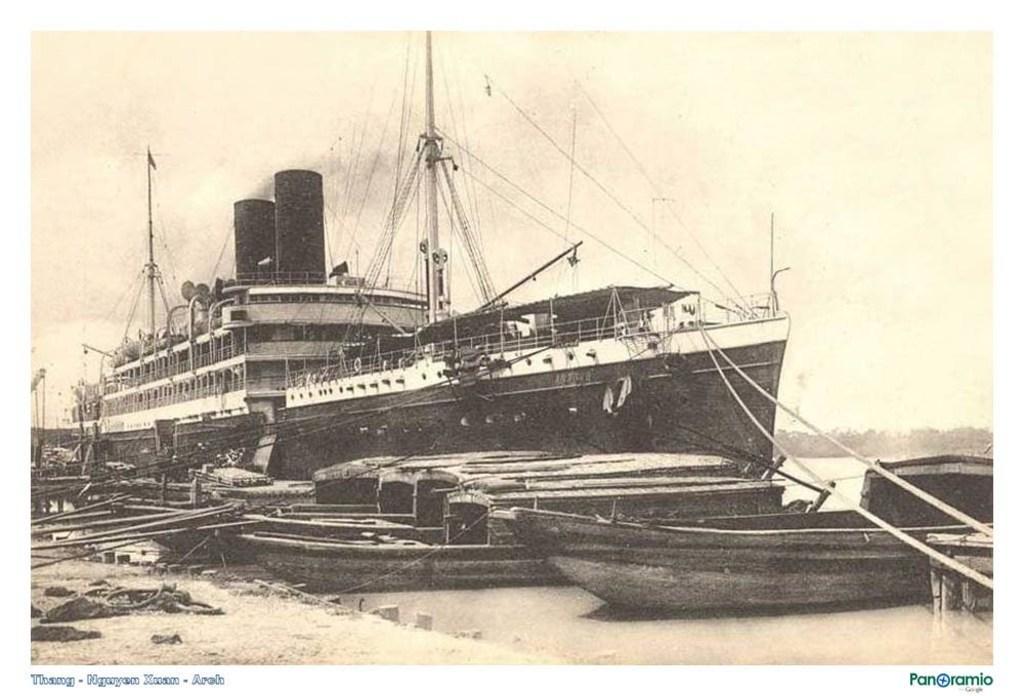Could you give a brief overview of what you see in this image? In this black and white image, there are boats and a ship on the water. On the left bottom, there is the path and a rope on it. In the background, there is sky and the cloud and trees on the right. 